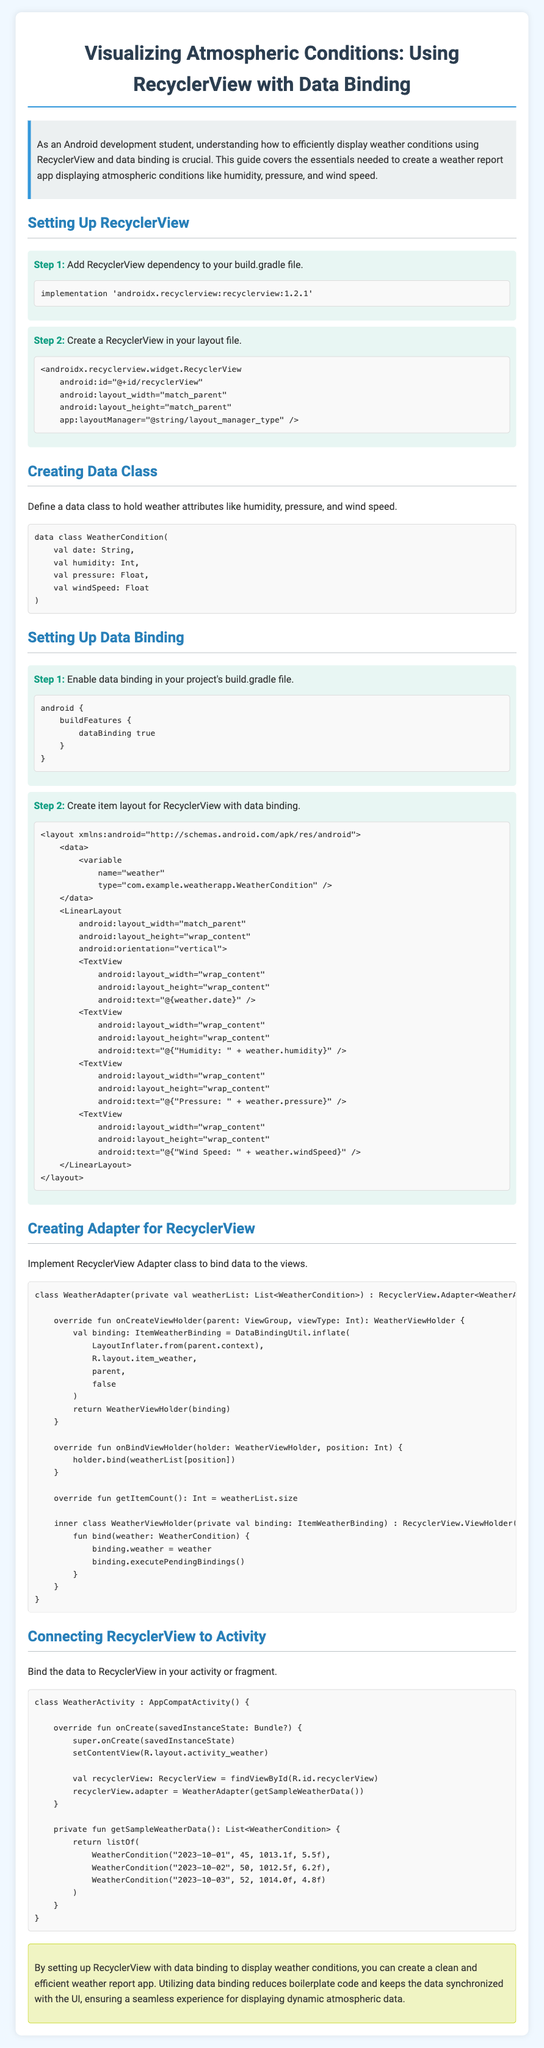What is the title of the document? The title provides the main subject and focus of the document, which is "Weather Report: Atmospheric Conditions."
Answer: Weather Report: Atmospheric Conditions What dependency needs to be added for RecyclerView? The document specifies that the RecyclerView dependency is 'androidx.recyclerview:recyclerview:1.2.1'.
Answer: androidx.recyclerview:recyclerview:1.2.1 What data class is created for weather attributes? The data class defined in the document is named WeatherCondition.
Answer: WeatherCondition How many steps are there in setting up Data Binding? The document outlines two steps under the section for setting up Data Binding.
Answer: 2 What is one of the weather attributes mentioned in the data class? The document lists humidity, pressure, and wind speed as attributes of the WeatherCondition class.
Answer: humidity What is the layout type used for the RecyclerView item file? The layout type for each item in the RecyclerView is defined as LinearLayout.
Answer: LinearLayout How many sample weather data entries are provided in the activity code? The activity code defines a function that returns three sample weather entries.
Answer: 3 What color is used for section headings in the document? The section heading color specified in the document is #2980b9.
Answer: #2980b9 What is the primary function of the WeatherAdapter class? The WeatherAdapter class is responsible for binding data from the weather list to the views.
Answer: Binding data 